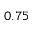Convert formula to latex. <formula><loc_0><loc_0><loc_500><loc_500>0 . 7 5</formula> 